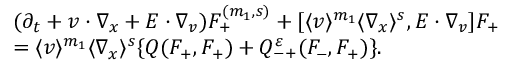Convert formula to latex. <formula><loc_0><loc_0><loc_500><loc_500>\begin{array} { r l } & { ( \partial _ { t } + v \cdot \nabla _ { x } + E \cdot \nabla _ { v } ) F _ { + } ^ { ( m _ { 1 } , s ) } + [ \langle v \rangle ^ { m _ { 1 } } \langle \nabla _ { x } \rangle ^ { s } , E \cdot \nabla _ { v } ] F _ { + } } \\ & { = \langle v \rangle ^ { m _ { 1 } } \langle \nabla _ { x } \rangle ^ { s } \{ Q ( F _ { + } , F _ { + } ) + Q _ { - + } ^ { \varepsilon } ( F _ { - } , F _ { + } ) \} . } \end{array}</formula> 